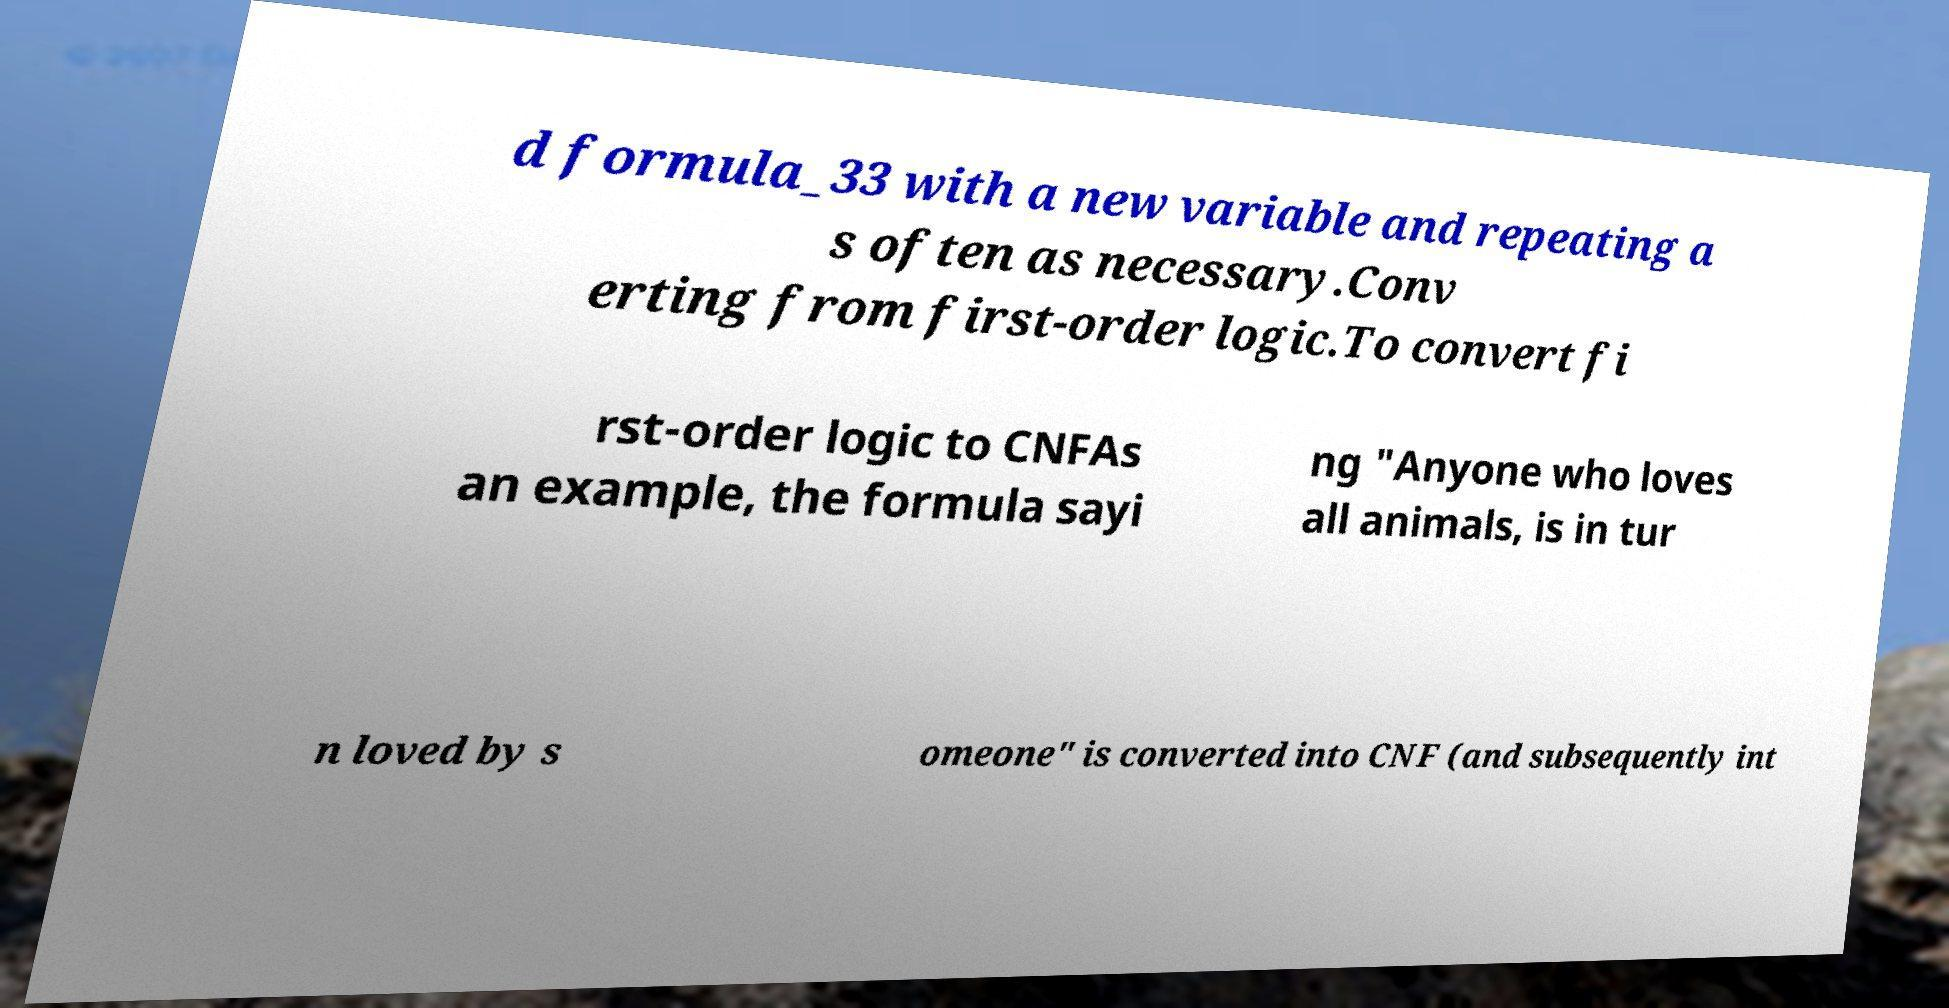Please identify and transcribe the text found in this image. d formula_33 with a new variable and repeating a s often as necessary.Conv erting from first-order logic.To convert fi rst-order logic to CNFAs an example, the formula sayi ng "Anyone who loves all animals, is in tur n loved by s omeone" is converted into CNF (and subsequently int 